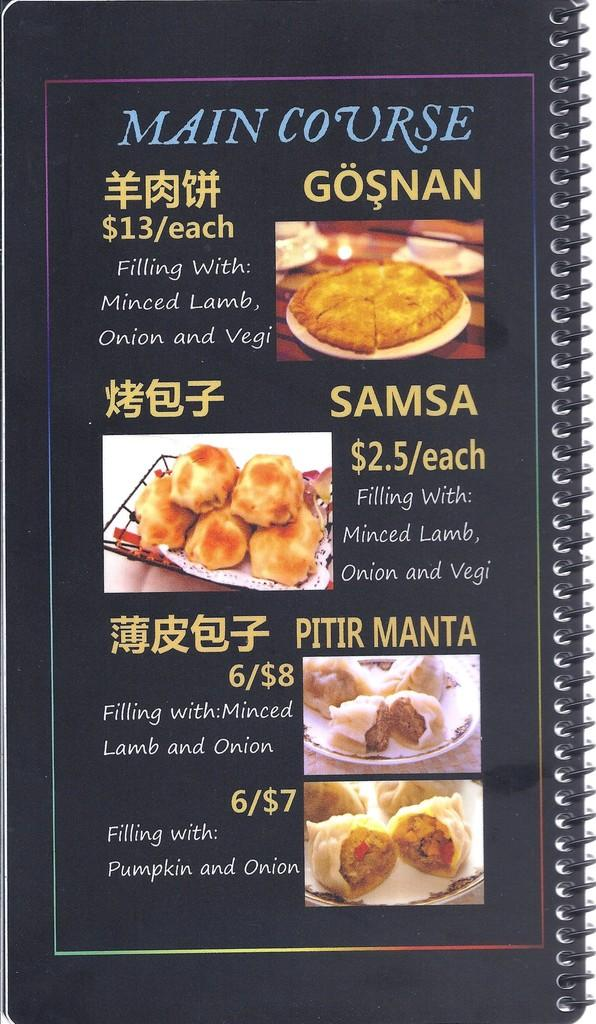What is present in the image related to reading material? There is a book in the image. What type of content is included in the book? The book has images and text. What type of juice can be seen being poured from a curtain in the image? There is no juice or curtain present in the image; it only features a book with images and text. 